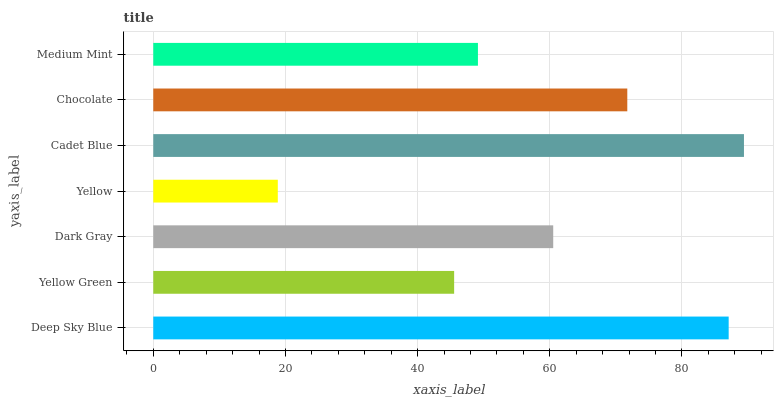Is Yellow the minimum?
Answer yes or no. Yes. Is Cadet Blue the maximum?
Answer yes or no. Yes. Is Yellow Green the minimum?
Answer yes or no. No. Is Yellow Green the maximum?
Answer yes or no. No. Is Deep Sky Blue greater than Yellow Green?
Answer yes or no. Yes. Is Yellow Green less than Deep Sky Blue?
Answer yes or no. Yes. Is Yellow Green greater than Deep Sky Blue?
Answer yes or no. No. Is Deep Sky Blue less than Yellow Green?
Answer yes or no. No. Is Dark Gray the high median?
Answer yes or no. Yes. Is Dark Gray the low median?
Answer yes or no. Yes. Is Medium Mint the high median?
Answer yes or no. No. Is Cadet Blue the low median?
Answer yes or no. No. 